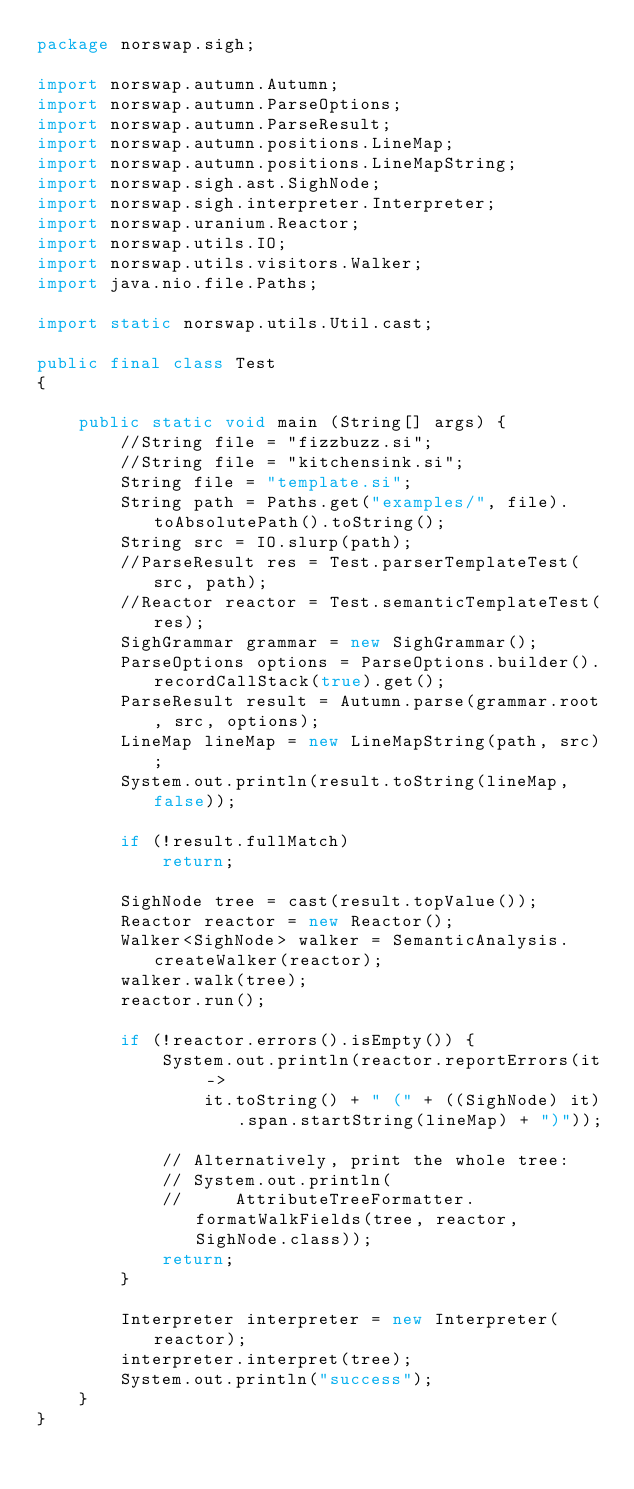Convert code to text. <code><loc_0><loc_0><loc_500><loc_500><_Java_>package norswap.sigh;

import norswap.autumn.Autumn;
import norswap.autumn.ParseOptions;
import norswap.autumn.ParseResult;
import norswap.autumn.positions.LineMap;
import norswap.autumn.positions.LineMapString;
import norswap.sigh.ast.SighNode;
import norswap.sigh.interpreter.Interpreter;
import norswap.uranium.Reactor;
import norswap.utils.IO;
import norswap.utils.visitors.Walker;
import java.nio.file.Paths;

import static norswap.utils.Util.cast;

public final class Test
{

    public static void main (String[] args) {
        //String file = "fizzbuzz.si";
        //String file = "kitchensink.si";
        String file = "template.si";
        String path = Paths.get("examples/", file).toAbsolutePath().toString();
        String src = IO.slurp(path);
        //ParseResult res = Test.parserTemplateTest(src, path);
        //Reactor reactor = Test.semanticTemplateTest(res);
        SighGrammar grammar = new SighGrammar();
        ParseOptions options = ParseOptions.builder().recordCallStack(true).get();
        ParseResult result = Autumn.parse(grammar.root, src, options);
        LineMap lineMap = new LineMapString(path, src);
        System.out.println(result.toString(lineMap, false));

        if (!result.fullMatch)
            return;

        SighNode tree = cast(result.topValue());
        Reactor reactor = new Reactor();
        Walker<SighNode> walker = SemanticAnalysis.createWalker(reactor);
        walker.walk(tree);
        reactor.run();

        if (!reactor.errors().isEmpty()) {
            System.out.println(reactor.reportErrors(it ->
                it.toString() + " (" + ((SighNode) it).span.startString(lineMap) + ")"));

            // Alternatively, print the whole tree:
            // System.out.println(
            //     AttributeTreeFormatter.formatWalkFields(tree, reactor, SighNode.class));
            return;
        }

        Interpreter interpreter = new Interpreter(reactor);
        interpreter.interpret(tree);
        System.out.println("success");
    }
}
</code> 